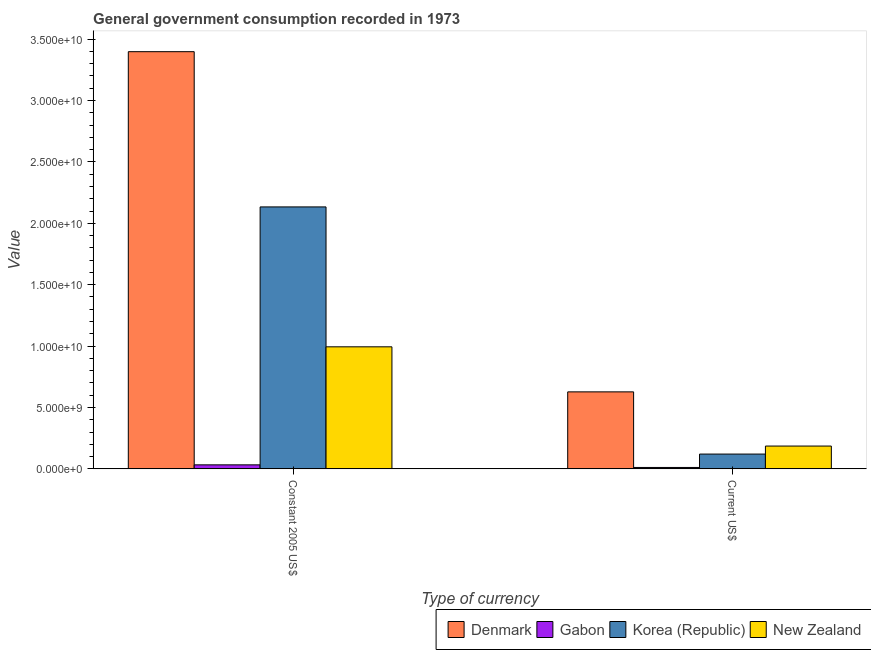How many bars are there on the 2nd tick from the right?
Offer a very short reply. 4. What is the label of the 2nd group of bars from the left?
Make the answer very short. Current US$. What is the value consumed in current us$ in Denmark?
Keep it short and to the point. 6.27e+09. Across all countries, what is the maximum value consumed in current us$?
Keep it short and to the point. 6.27e+09. Across all countries, what is the minimum value consumed in current us$?
Offer a terse response. 1.13e+08. In which country was the value consumed in current us$ maximum?
Keep it short and to the point. Denmark. In which country was the value consumed in current us$ minimum?
Your answer should be very brief. Gabon. What is the total value consumed in current us$ in the graph?
Offer a terse response. 9.44e+09. What is the difference between the value consumed in constant 2005 us$ in Gabon and that in Denmark?
Your response must be concise. -3.37e+1. What is the difference between the value consumed in constant 2005 us$ in Denmark and the value consumed in current us$ in Gabon?
Offer a very short reply. 3.39e+1. What is the average value consumed in constant 2005 us$ per country?
Keep it short and to the point. 1.64e+1. What is the difference between the value consumed in current us$ and value consumed in constant 2005 us$ in New Zealand?
Give a very brief answer. -8.08e+09. In how many countries, is the value consumed in current us$ greater than 9000000000 ?
Make the answer very short. 0. What is the ratio of the value consumed in constant 2005 us$ in New Zealand to that in Denmark?
Provide a short and direct response. 0.29. Is the value consumed in constant 2005 us$ in New Zealand less than that in Korea (Republic)?
Provide a short and direct response. Yes. In how many countries, is the value consumed in constant 2005 us$ greater than the average value consumed in constant 2005 us$ taken over all countries?
Offer a terse response. 2. What does the 2nd bar from the right in Constant 2005 US$ represents?
Give a very brief answer. Korea (Republic). Are all the bars in the graph horizontal?
Provide a succinct answer. No. How many countries are there in the graph?
Offer a very short reply. 4. What is the difference between two consecutive major ticks on the Y-axis?
Offer a terse response. 5.00e+09. Are the values on the major ticks of Y-axis written in scientific E-notation?
Provide a succinct answer. Yes. Does the graph contain grids?
Give a very brief answer. No. How many legend labels are there?
Make the answer very short. 4. What is the title of the graph?
Your answer should be compact. General government consumption recorded in 1973. What is the label or title of the X-axis?
Offer a very short reply. Type of currency. What is the label or title of the Y-axis?
Make the answer very short. Value. What is the Value in Denmark in Constant 2005 US$?
Keep it short and to the point. 3.40e+1. What is the Value of Gabon in Constant 2005 US$?
Your answer should be compact. 3.26e+08. What is the Value in Korea (Republic) in Constant 2005 US$?
Your answer should be very brief. 2.13e+1. What is the Value in New Zealand in Constant 2005 US$?
Give a very brief answer. 9.94e+09. What is the Value in Denmark in Current US$?
Make the answer very short. 6.27e+09. What is the Value of Gabon in Current US$?
Provide a short and direct response. 1.13e+08. What is the Value in Korea (Republic) in Current US$?
Provide a short and direct response. 1.20e+09. What is the Value of New Zealand in Current US$?
Your answer should be compact. 1.86e+09. Across all Type of currency, what is the maximum Value of Denmark?
Ensure brevity in your answer.  3.40e+1. Across all Type of currency, what is the maximum Value in Gabon?
Your answer should be compact. 3.26e+08. Across all Type of currency, what is the maximum Value of Korea (Republic)?
Offer a terse response. 2.13e+1. Across all Type of currency, what is the maximum Value of New Zealand?
Provide a short and direct response. 9.94e+09. Across all Type of currency, what is the minimum Value in Denmark?
Ensure brevity in your answer.  6.27e+09. Across all Type of currency, what is the minimum Value of Gabon?
Make the answer very short. 1.13e+08. Across all Type of currency, what is the minimum Value in Korea (Republic)?
Your response must be concise. 1.20e+09. Across all Type of currency, what is the minimum Value of New Zealand?
Keep it short and to the point. 1.86e+09. What is the total Value of Denmark in the graph?
Your answer should be very brief. 4.02e+1. What is the total Value of Gabon in the graph?
Your answer should be compact. 4.38e+08. What is the total Value in Korea (Republic) in the graph?
Offer a very short reply. 2.25e+1. What is the total Value of New Zealand in the graph?
Keep it short and to the point. 1.18e+1. What is the difference between the Value of Denmark in Constant 2005 US$ and that in Current US$?
Keep it short and to the point. 2.77e+1. What is the difference between the Value of Gabon in Constant 2005 US$ and that in Current US$?
Give a very brief answer. 2.13e+08. What is the difference between the Value of Korea (Republic) in Constant 2005 US$ and that in Current US$?
Your answer should be compact. 2.01e+1. What is the difference between the Value of New Zealand in Constant 2005 US$ and that in Current US$?
Provide a succinct answer. 8.08e+09. What is the difference between the Value in Denmark in Constant 2005 US$ and the Value in Gabon in Current US$?
Ensure brevity in your answer.  3.39e+1. What is the difference between the Value in Denmark in Constant 2005 US$ and the Value in Korea (Republic) in Current US$?
Your answer should be very brief. 3.28e+1. What is the difference between the Value of Denmark in Constant 2005 US$ and the Value of New Zealand in Current US$?
Offer a very short reply. 3.21e+1. What is the difference between the Value of Gabon in Constant 2005 US$ and the Value of Korea (Republic) in Current US$?
Ensure brevity in your answer.  -8.77e+08. What is the difference between the Value of Gabon in Constant 2005 US$ and the Value of New Zealand in Current US$?
Your answer should be compact. -1.53e+09. What is the difference between the Value of Korea (Republic) in Constant 2005 US$ and the Value of New Zealand in Current US$?
Offer a terse response. 1.95e+1. What is the average Value of Denmark per Type of currency?
Your response must be concise. 2.01e+1. What is the average Value in Gabon per Type of currency?
Provide a short and direct response. 2.19e+08. What is the average Value in Korea (Republic) per Type of currency?
Your answer should be compact. 1.13e+1. What is the average Value in New Zealand per Type of currency?
Your answer should be very brief. 5.90e+09. What is the difference between the Value in Denmark and Value in Gabon in Constant 2005 US$?
Ensure brevity in your answer.  3.37e+1. What is the difference between the Value of Denmark and Value of Korea (Republic) in Constant 2005 US$?
Your answer should be compact. 1.26e+1. What is the difference between the Value of Denmark and Value of New Zealand in Constant 2005 US$?
Ensure brevity in your answer.  2.40e+1. What is the difference between the Value of Gabon and Value of Korea (Republic) in Constant 2005 US$?
Your answer should be very brief. -2.10e+1. What is the difference between the Value of Gabon and Value of New Zealand in Constant 2005 US$?
Offer a terse response. -9.61e+09. What is the difference between the Value of Korea (Republic) and Value of New Zealand in Constant 2005 US$?
Provide a short and direct response. 1.14e+1. What is the difference between the Value in Denmark and Value in Gabon in Current US$?
Provide a short and direct response. 6.16e+09. What is the difference between the Value of Denmark and Value of Korea (Republic) in Current US$?
Provide a short and direct response. 5.07e+09. What is the difference between the Value of Denmark and Value of New Zealand in Current US$?
Ensure brevity in your answer.  4.41e+09. What is the difference between the Value in Gabon and Value in Korea (Republic) in Current US$?
Provide a short and direct response. -1.09e+09. What is the difference between the Value in Gabon and Value in New Zealand in Current US$?
Provide a succinct answer. -1.74e+09. What is the difference between the Value of Korea (Republic) and Value of New Zealand in Current US$?
Provide a short and direct response. -6.53e+08. What is the ratio of the Value in Denmark in Constant 2005 US$ to that in Current US$?
Provide a short and direct response. 5.42. What is the ratio of the Value of Gabon in Constant 2005 US$ to that in Current US$?
Offer a very short reply. 2.89. What is the ratio of the Value in Korea (Republic) in Constant 2005 US$ to that in Current US$?
Your answer should be very brief. 17.74. What is the ratio of the Value in New Zealand in Constant 2005 US$ to that in Current US$?
Keep it short and to the point. 5.36. What is the difference between the highest and the second highest Value of Denmark?
Offer a very short reply. 2.77e+1. What is the difference between the highest and the second highest Value of Gabon?
Make the answer very short. 2.13e+08. What is the difference between the highest and the second highest Value in Korea (Republic)?
Your answer should be very brief. 2.01e+1. What is the difference between the highest and the second highest Value of New Zealand?
Offer a terse response. 8.08e+09. What is the difference between the highest and the lowest Value in Denmark?
Your answer should be compact. 2.77e+1. What is the difference between the highest and the lowest Value of Gabon?
Offer a terse response. 2.13e+08. What is the difference between the highest and the lowest Value of Korea (Republic)?
Offer a very short reply. 2.01e+1. What is the difference between the highest and the lowest Value of New Zealand?
Make the answer very short. 8.08e+09. 